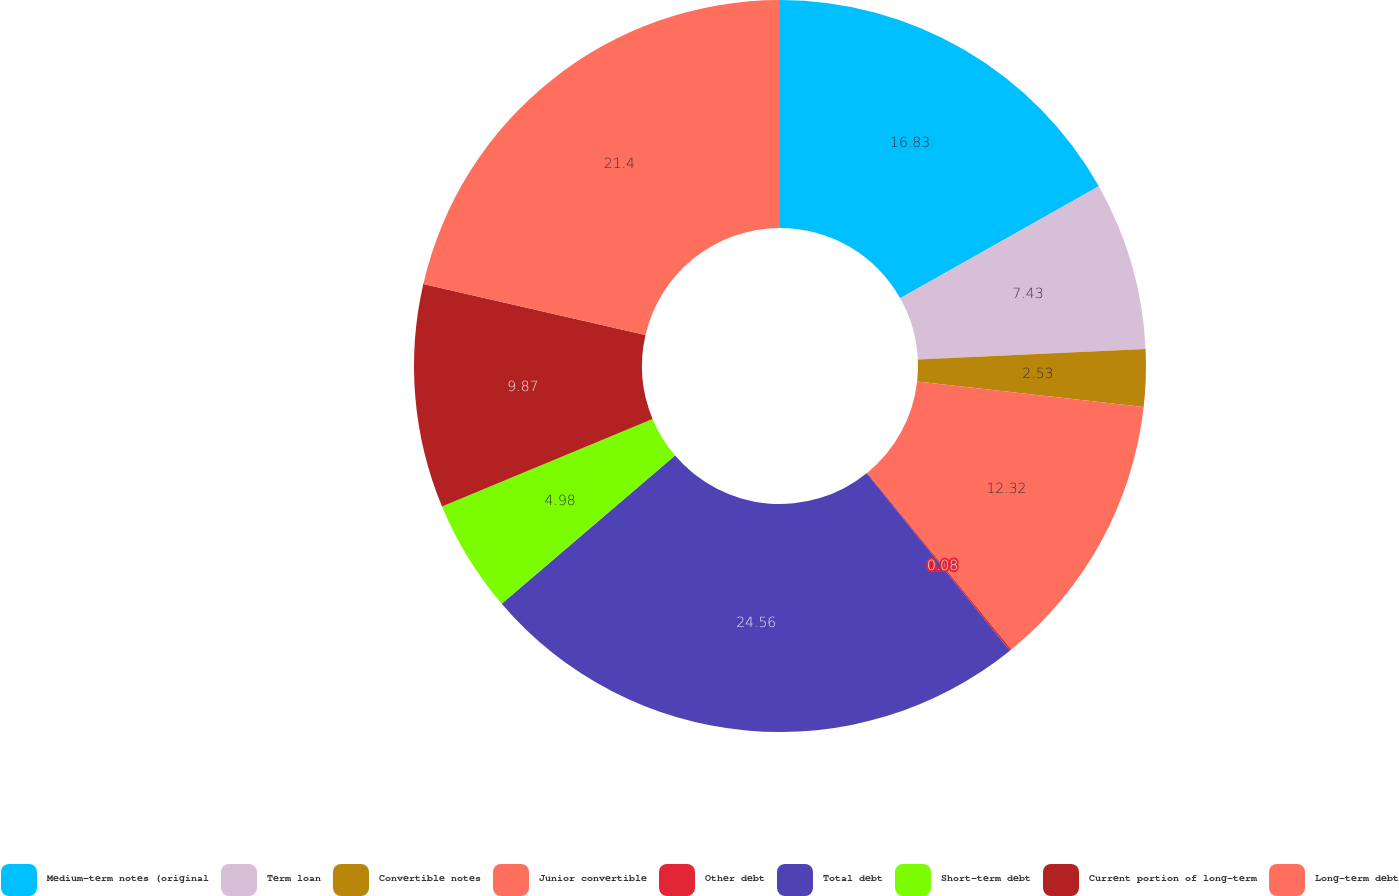Convert chart. <chart><loc_0><loc_0><loc_500><loc_500><pie_chart><fcel>Medium-term notes (original<fcel>Term loan<fcel>Convertible notes<fcel>Junior convertible<fcel>Other debt<fcel>Total debt<fcel>Short-term debt<fcel>Current portion of long-term<fcel>Long-term debt<nl><fcel>16.83%<fcel>7.43%<fcel>2.53%<fcel>12.32%<fcel>0.08%<fcel>24.56%<fcel>4.98%<fcel>9.87%<fcel>21.4%<nl></chart> 